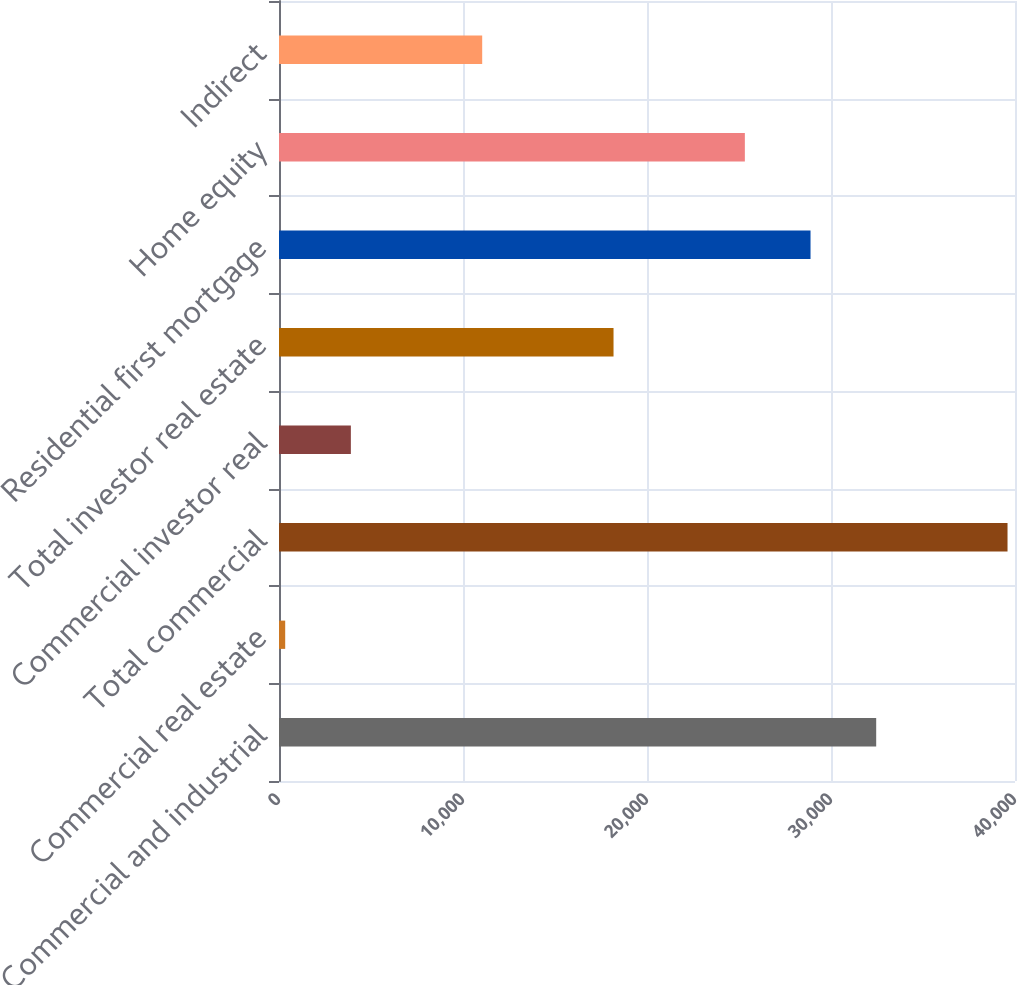Convert chart. <chart><loc_0><loc_0><loc_500><loc_500><bar_chart><fcel>Commercial and industrial<fcel>Commercial real estate<fcel>Total commercial<fcel>Commercial investor real<fcel>Total investor real estate<fcel>Residential first mortgage<fcel>Home equity<fcel>Indirect<nl><fcel>32456.2<fcel>337<fcel>39593.8<fcel>3905.8<fcel>18181<fcel>28887.4<fcel>25318.6<fcel>11043.4<nl></chart> 